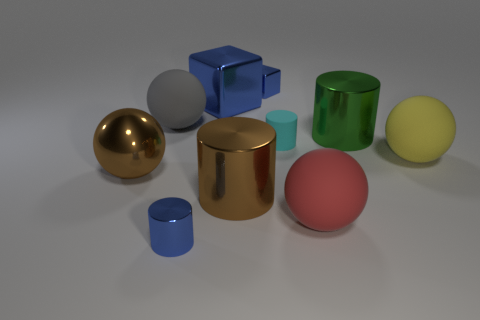How many blue blocks must be subtracted to get 1 blue blocks? 1 Subtract all gray cubes. Subtract all purple cylinders. How many cubes are left? 2 Subtract all cubes. How many objects are left? 8 Add 8 purple rubber objects. How many purple rubber objects exist? 8 Subtract 0 cyan blocks. How many objects are left? 10 Subtract all gray things. Subtract all spheres. How many objects are left? 5 Add 5 rubber objects. How many rubber objects are left? 9 